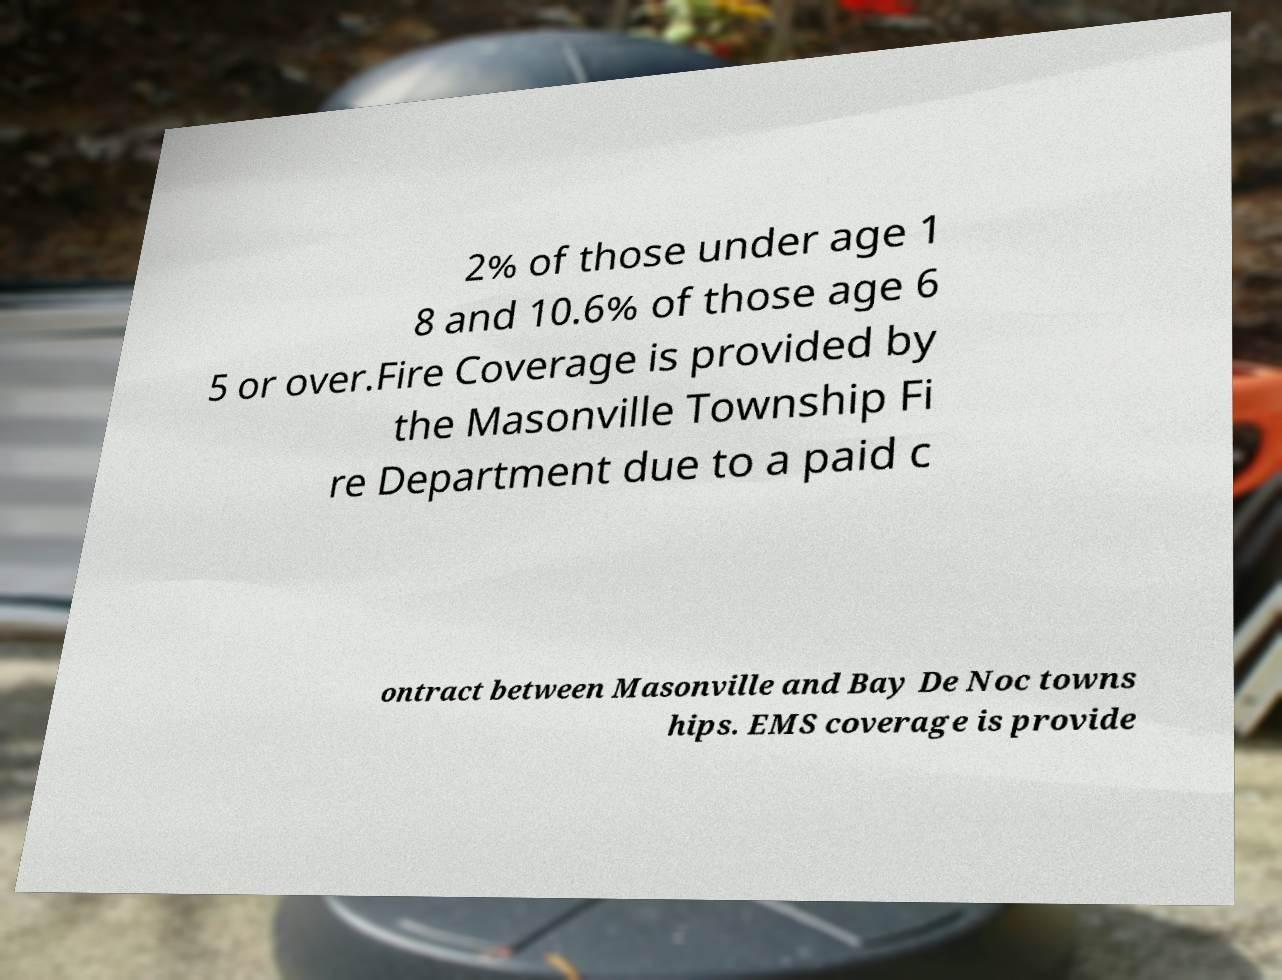Can you accurately transcribe the text from the provided image for me? 2% of those under age 1 8 and 10.6% of those age 6 5 or over.Fire Coverage is provided by the Masonville Township Fi re Department due to a paid c ontract between Masonville and Bay De Noc towns hips. EMS coverage is provide 